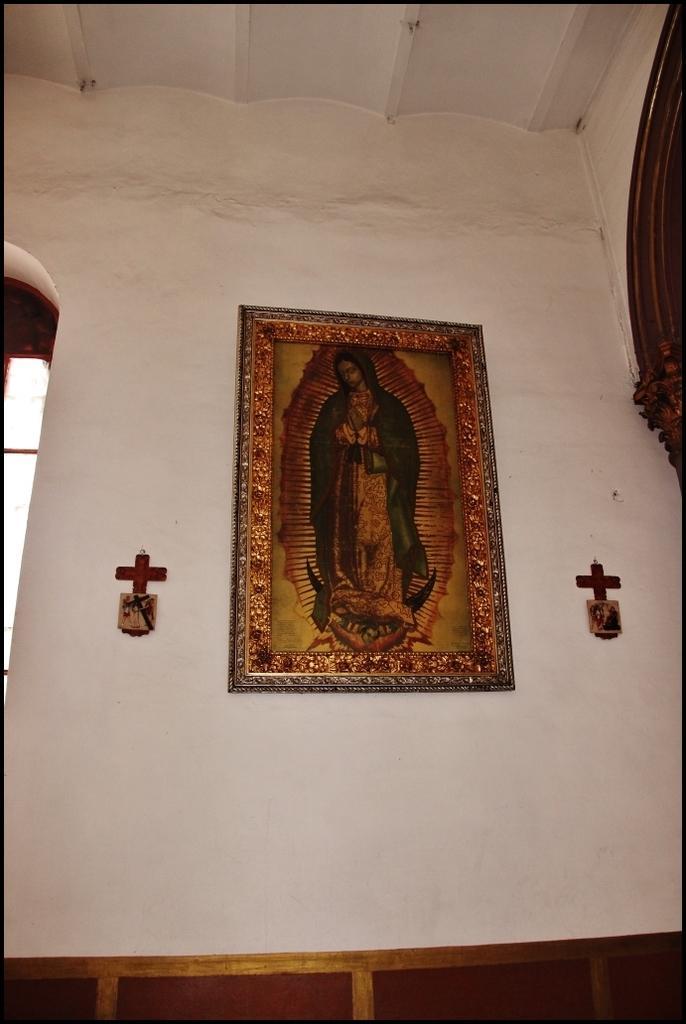Can you describe this image briefly? In this picture I can see the inside view of the church. In the center I can see the frame which is placed on the wall. Beside that I can see the cross mark. On the left there is a window. On the right I can see the wooden frame. At the top I can see the roof. 